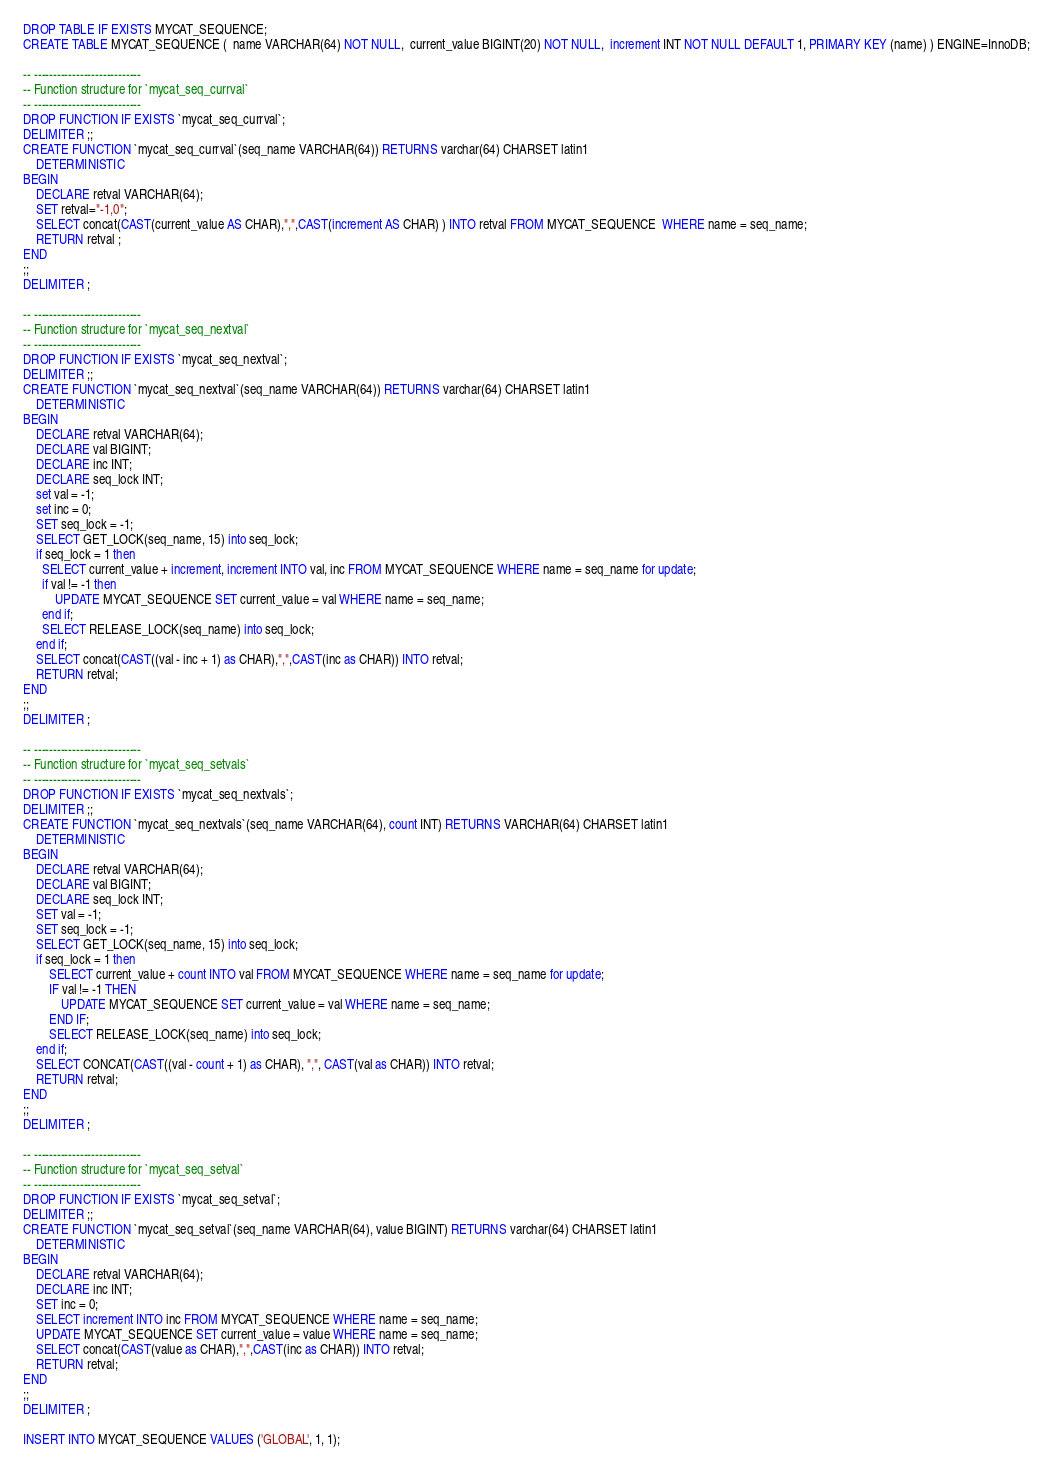<code> <loc_0><loc_0><loc_500><loc_500><_SQL_>DROP TABLE IF EXISTS MYCAT_SEQUENCE;
CREATE TABLE MYCAT_SEQUENCE (  name VARCHAR(64) NOT NULL,  current_value BIGINT(20) NOT NULL,  increment INT NOT NULL DEFAULT 1, PRIMARY KEY (name) ) ENGINE=InnoDB;

-- ----------------------------
-- Function structure for `mycat_seq_currval`
-- ----------------------------
DROP FUNCTION IF EXISTS `mycat_seq_currval`;
DELIMITER ;;
CREATE FUNCTION `mycat_seq_currval`(seq_name VARCHAR(64)) RETURNS varchar(64) CHARSET latin1
    DETERMINISTIC
BEGIN
    DECLARE retval VARCHAR(64);
    SET retval="-1,0";
    SELECT concat(CAST(current_value AS CHAR),",",CAST(increment AS CHAR) ) INTO retval FROM MYCAT_SEQUENCE  WHERE name = seq_name;
    RETURN retval ;
END
;;
DELIMITER ;

-- ----------------------------
-- Function structure for `mycat_seq_nextval`
-- ----------------------------
DROP FUNCTION IF EXISTS `mycat_seq_nextval`;
DELIMITER ;;
CREATE FUNCTION `mycat_seq_nextval`(seq_name VARCHAR(64)) RETURNS varchar(64) CHARSET latin1
    DETERMINISTIC
BEGIN
    DECLARE retval VARCHAR(64);
    DECLARE val BIGINT;
    DECLARE inc INT;
    DECLARE seq_lock INT;
    set val = -1;
    set inc = 0;
    SET seq_lock = -1;
    SELECT GET_LOCK(seq_name, 15) into seq_lock;
    if seq_lock = 1 then
      SELECT current_value + increment, increment INTO val, inc FROM MYCAT_SEQUENCE WHERE name = seq_name for update;
      if val != -1 then
          UPDATE MYCAT_SEQUENCE SET current_value = val WHERE name = seq_name;
      end if;
      SELECT RELEASE_LOCK(seq_name) into seq_lock;
    end if;
    SELECT concat(CAST((val - inc + 1) as CHAR),",",CAST(inc as CHAR)) INTO retval;
    RETURN retval;
END
;;
DELIMITER ;

-- ----------------------------
-- Function structure for `mycat_seq_setvals`
-- ----------------------------
DROP FUNCTION IF EXISTS `mycat_seq_nextvals`;
DELIMITER ;;
CREATE FUNCTION `mycat_seq_nextvals`(seq_name VARCHAR(64), count INT) RETURNS VARCHAR(64) CHARSET latin1
    DETERMINISTIC
BEGIN
    DECLARE retval VARCHAR(64);
    DECLARE val BIGINT;
    DECLARE seq_lock INT;
    SET val = -1;
    SET seq_lock = -1;
    SELECT GET_LOCK(seq_name, 15) into seq_lock;
    if seq_lock = 1 then
        SELECT current_value + count INTO val FROM MYCAT_SEQUENCE WHERE name = seq_name for update;
        IF val != -1 THEN
            UPDATE MYCAT_SEQUENCE SET current_value = val WHERE name = seq_name;
        END IF;
        SELECT RELEASE_LOCK(seq_name) into seq_lock;
    end if;
    SELECT CONCAT(CAST((val - count + 1) as CHAR), ",", CAST(val as CHAR)) INTO retval;
    RETURN retval;
END
;;
DELIMITER ;

-- ----------------------------
-- Function structure for `mycat_seq_setval`
-- ----------------------------
DROP FUNCTION IF EXISTS `mycat_seq_setval`;
DELIMITER ;;
CREATE FUNCTION `mycat_seq_setval`(seq_name VARCHAR(64), value BIGINT) RETURNS varchar(64) CHARSET latin1
    DETERMINISTIC
BEGIN
    DECLARE retval VARCHAR(64);
    DECLARE inc INT;
    SET inc = 0;
    SELECT increment INTO inc FROM MYCAT_SEQUENCE WHERE name = seq_name;
    UPDATE MYCAT_SEQUENCE SET current_value = value WHERE name = seq_name;
    SELECT concat(CAST(value as CHAR),",",CAST(inc as CHAR)) INTO retval;
    RETURN retval;
END
;;
DELIMITER ;

INSERT INTO MYCAT_SEQUENCE VALUES ('GLOBAL', 1, 1);</code> 